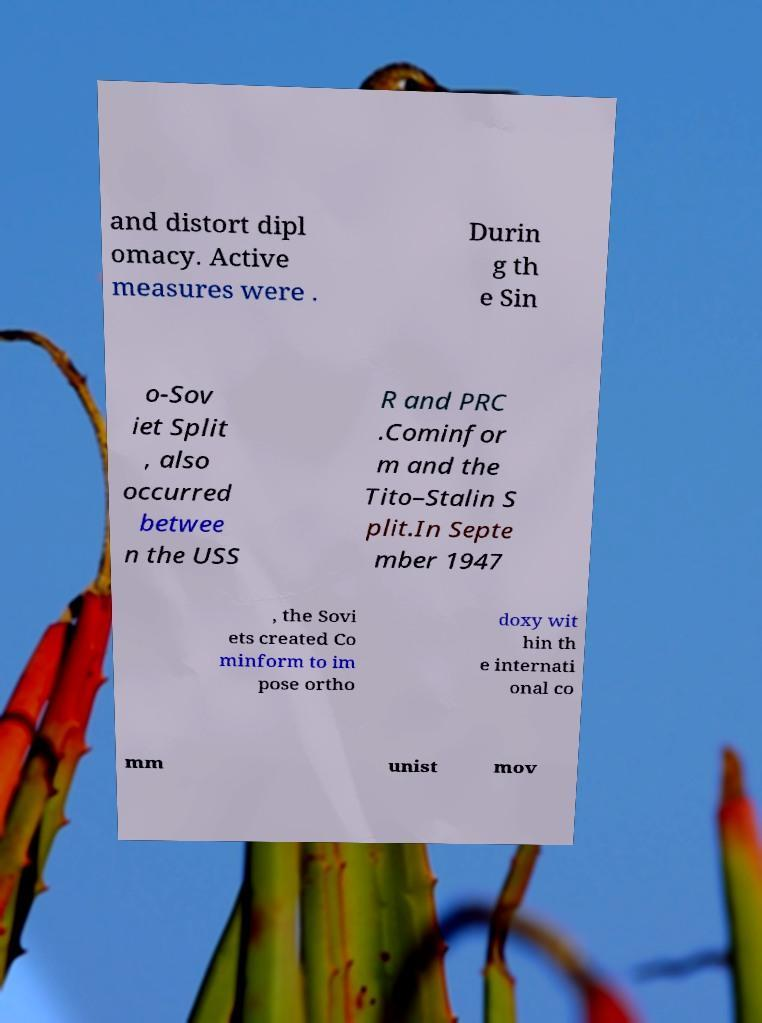Please read and relay the text visible in this image. What does it say? and distort dipl omacy. Active measures were . Durin g th e Sin o-Sov iet Split , also occurred betwee n the USS R and PRC .Cominfor m and the Tito–Stalin S plit.In Septe mber 1947 , the Sovi ets created Co minform to im pose ortho doxy wit hin th e internati onal co mm unist mov 